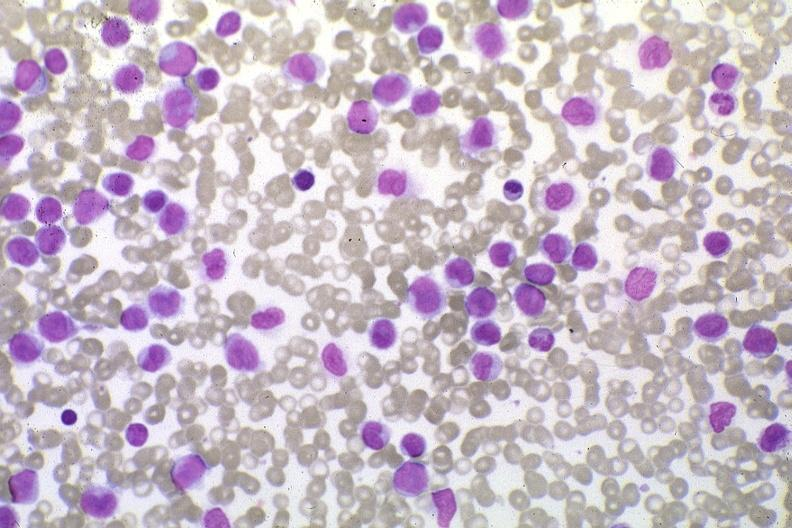s blood present?
Answer the question using a single word or phrase. Yes 